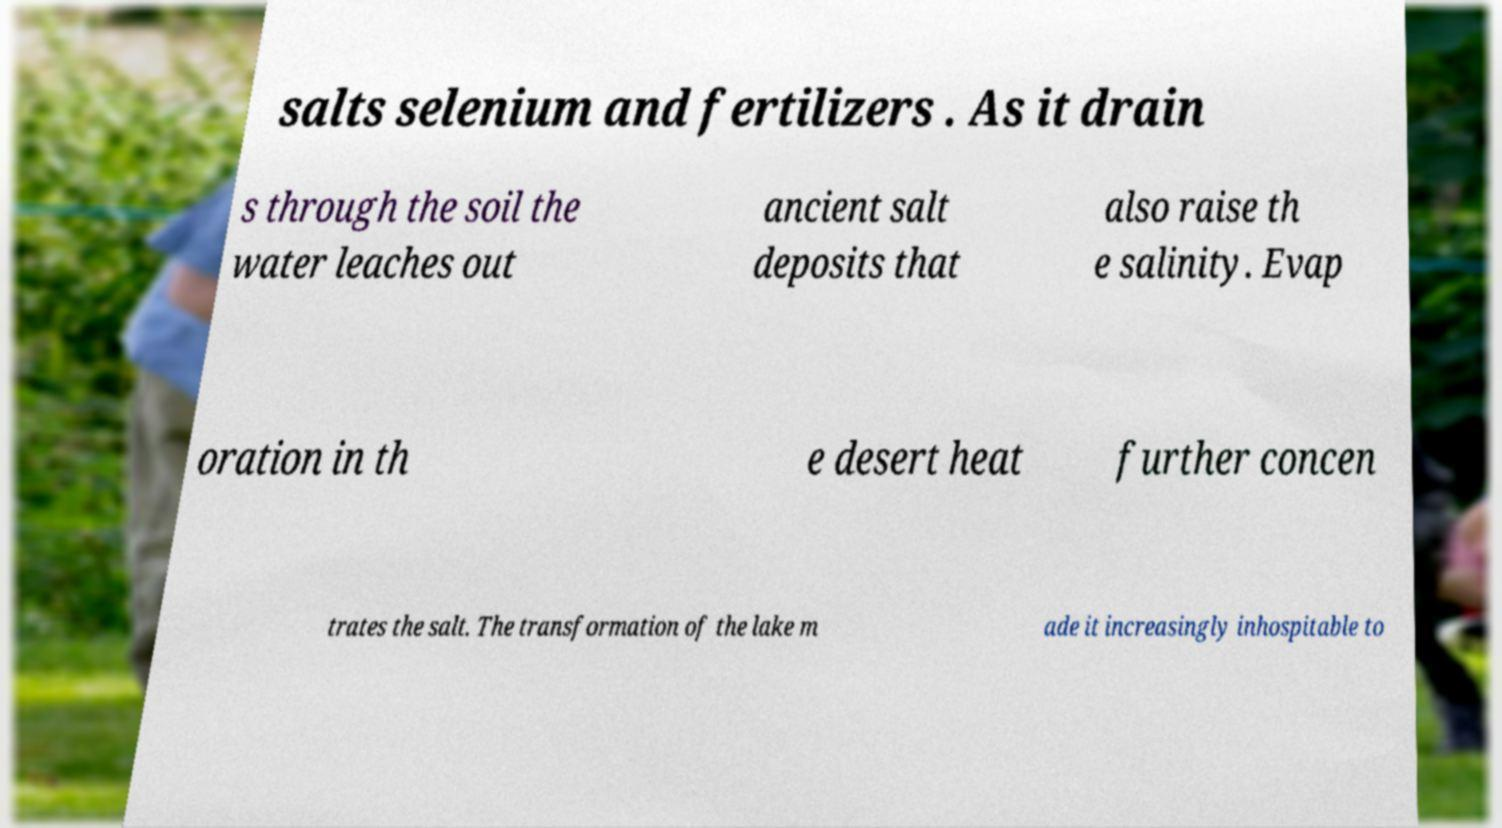There's text embedded in this image that I need extracted. Can you transcribe it verbatim? salts selenium and fertilizers . As it drain s through the soil the water leaches out ancient salt deposits that also raise th e salinity. Evap oration in th e desert heat further concen trates the salt. The transformation of the lake m ade it increasingly inhospitable to 